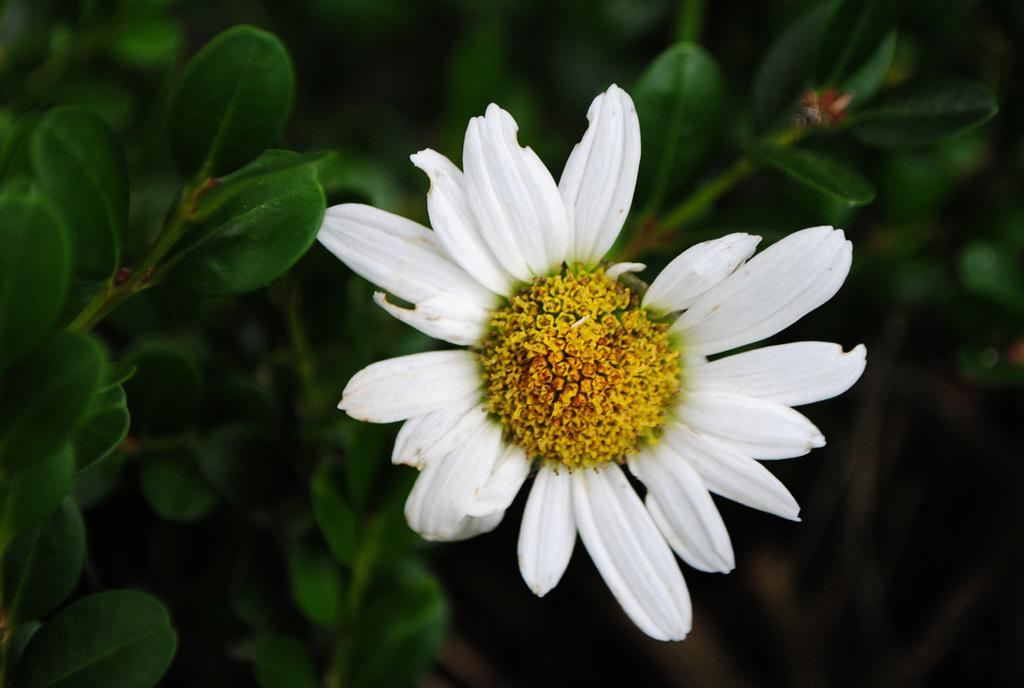What is the main subject of the image? There is a flower in the image. What can be seen in the background of the image? There are leaves in the background of the image. How would you describe the background of the image? The background is blurry. What type of power does the rat have in the image? There is no rat present in the image, so it is not possible to determine what power it might have. 